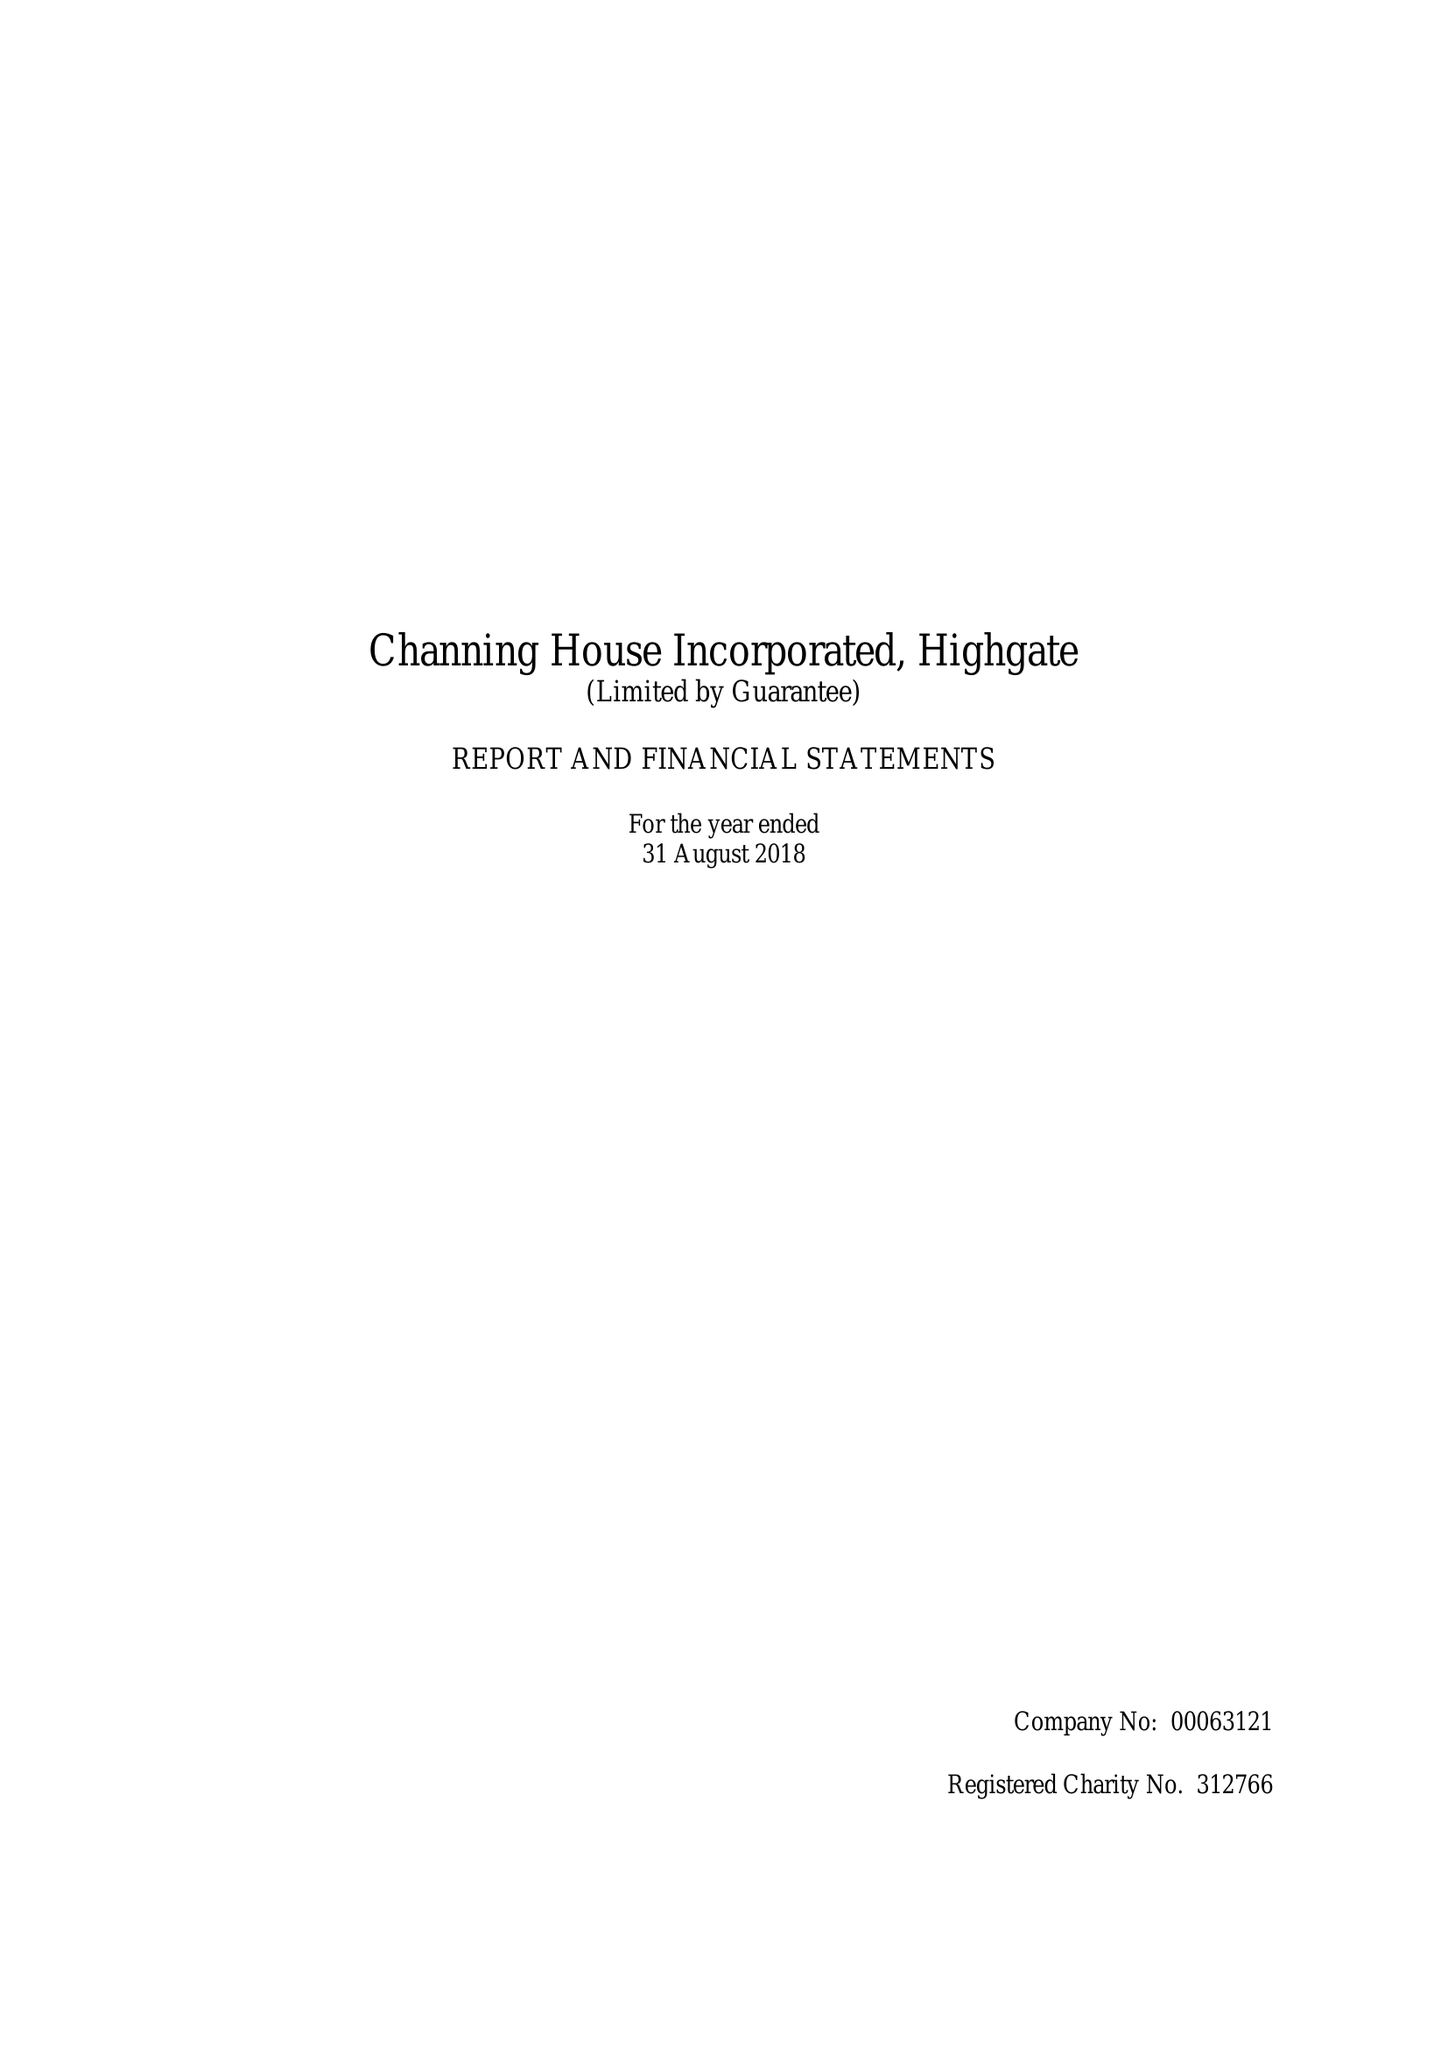What is the value for the address__postcode?
Answer the question using a single word or phrase. N6 5HF 